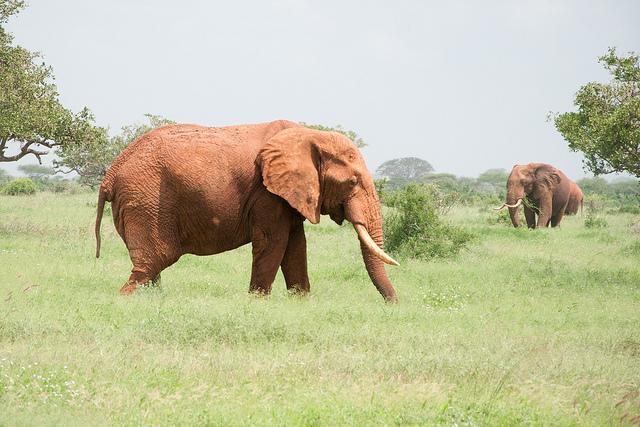How many elephants are there?
Short answer required. 2. How many tusk?
Keep it brief. 4. Is this a desert?
Be succinct. No. How many elephants?
Write a very short answer. 2. Is this animal in the wild?
Keep it brief. Yes. 